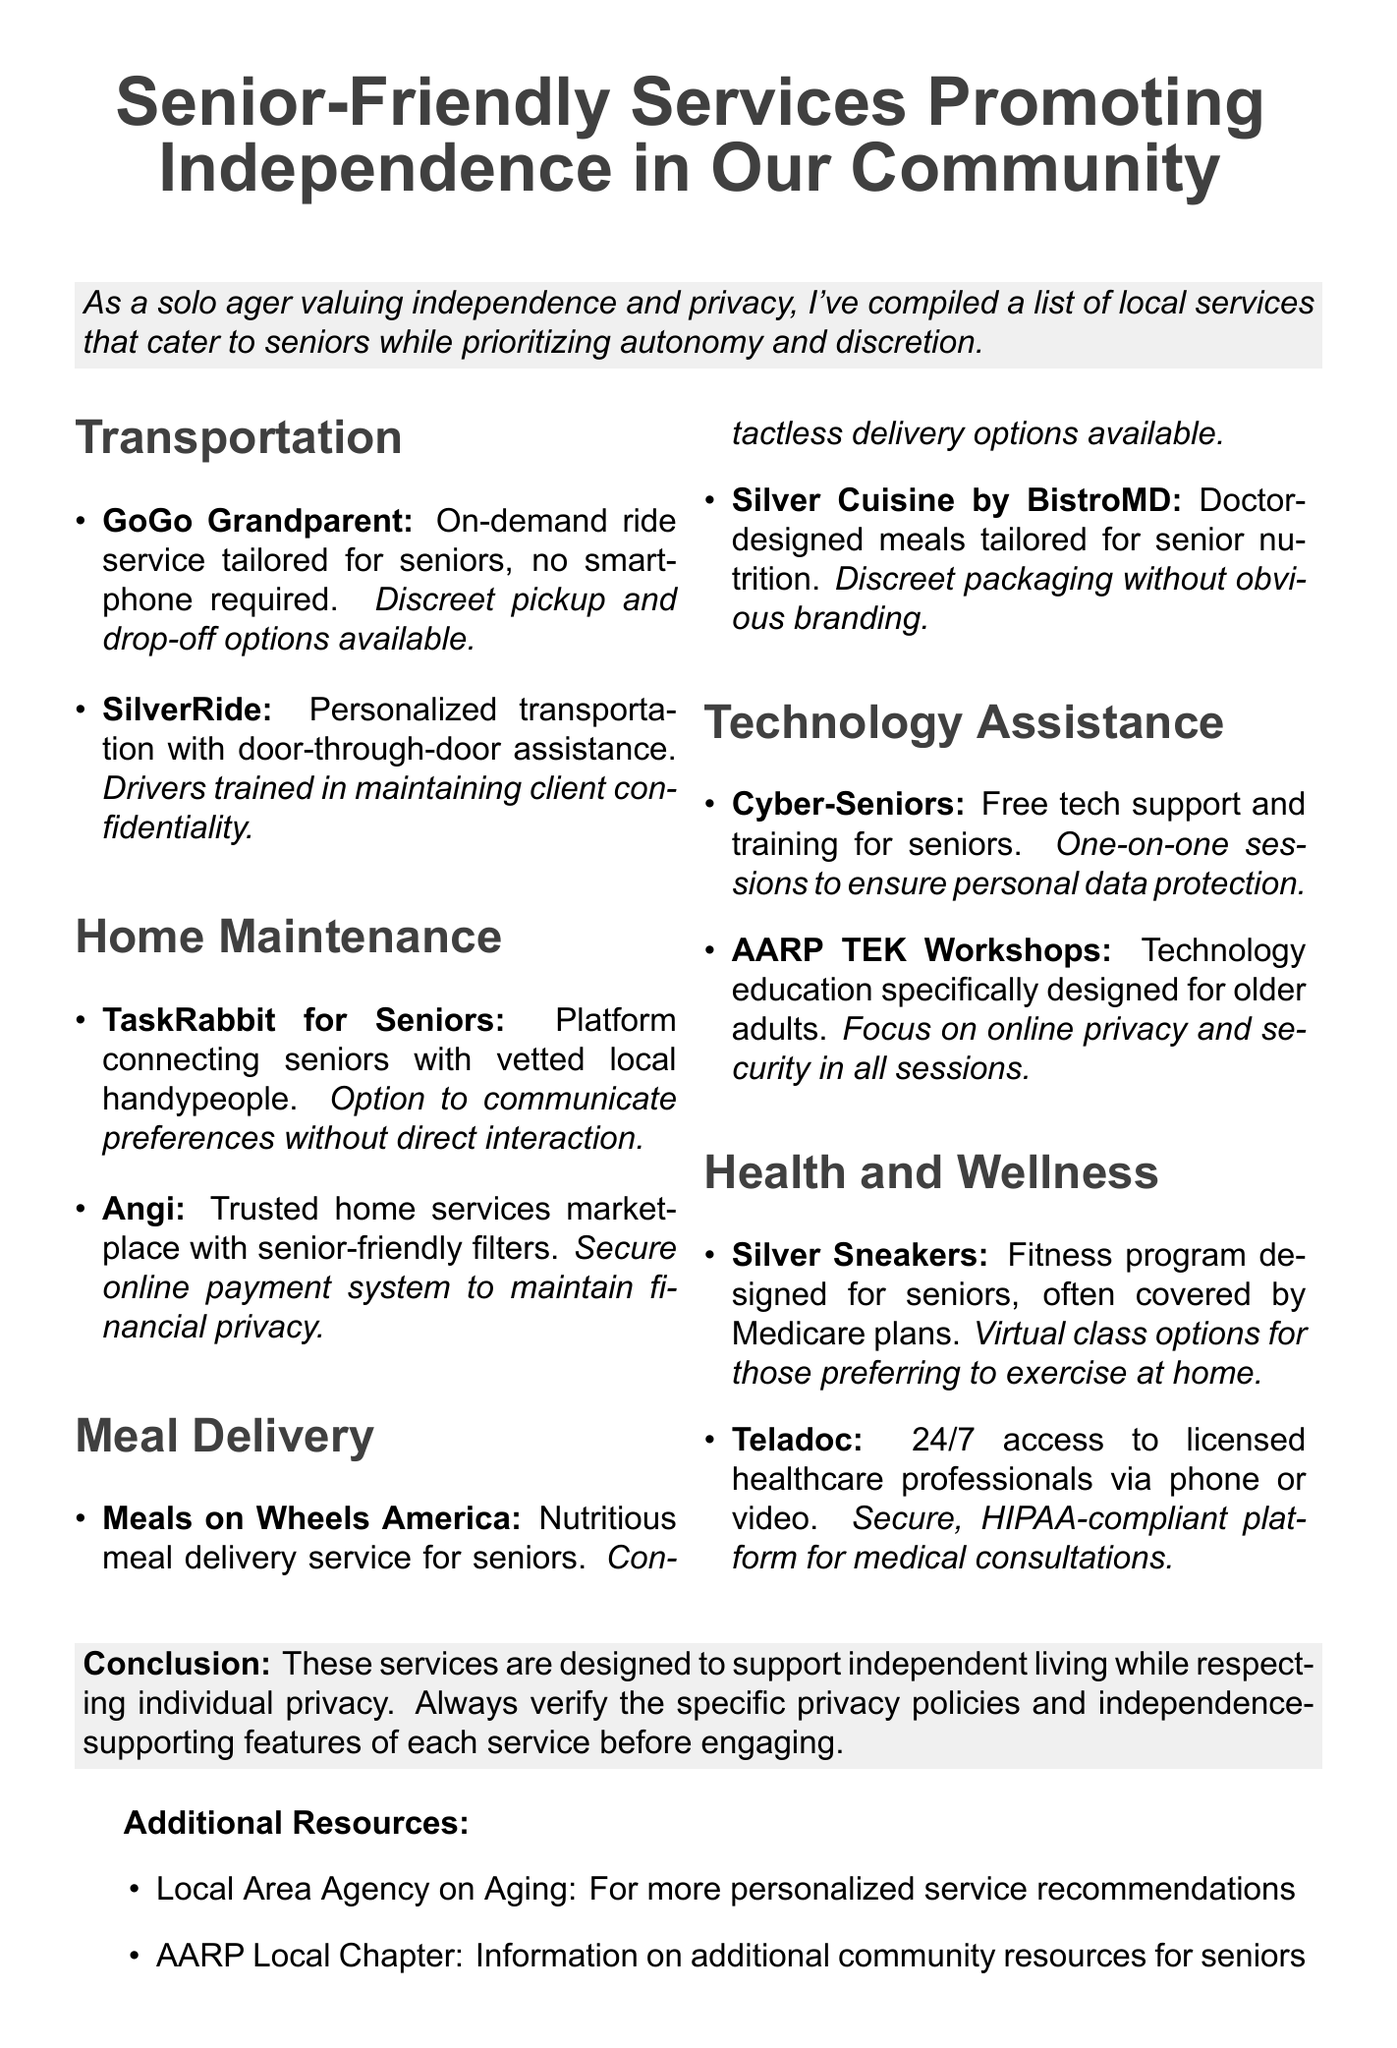What is the title of the memo? The title of the memo is stated clearly at the beginning, highlighting the focus on services for seniors.
Answer: Senior-Friendly Services Promoting Independence in Our Community What service is provided by GoGo Grandparent? GoGo Grandparent offers an on-demand ride service tailored specifically for seniors.
Answer: On-demand ride service tailored for seniors What privacy feature is highlighted for SilverRide? The memo specifies that drivers are trained to maintain client confidentiality which is a privacy feature.
Answer: Drivers trained in maintaining client confidentiality Which organization offers technology assistance specifically for seniors? Cyber-Seniors is mentioned as a service providing free tech support and training for seniors.
Answer: Cyber-Seniors What type of delivery options are available from Meals on Wheels America? The memo mentions that contactless delivery options are available for Meals on Wheels America.
Answer: Contactless delivery options available How many categories of services are listed in the memo? The memo outlines five distinct categories of services arranged for seniors.
Answer: Five What conclusion is drawn about the listed services? The conclusion emphasizes that these services support independent living while respecting privacy.
Answer: Support independent living while respecting individual privacy What additional resource is suggested for personalized service recommendations? The memo notes the Local Area Agency on Aging for more tailored service recommendations.
Answer: Local Area Agency on Aging What focus does AARP TEK Workshops have? The memo indicates that AARP TEK Workshops focus on online privacy and security during their sessions.
Answer: Focus on online privacy and security 